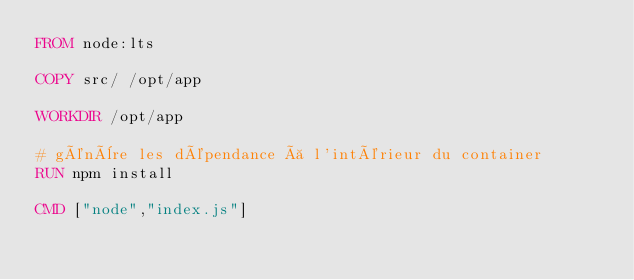<code> <loc_0><loc_0><loc_500><loc_500><_Dockerfile_>FROM node:lts

COPY src/ /opt/app

WORKDIR /opt/app

# génère les dépendance à l'intérieur du container
RUN npm install

CMD ["node","index.js"]
</code> 